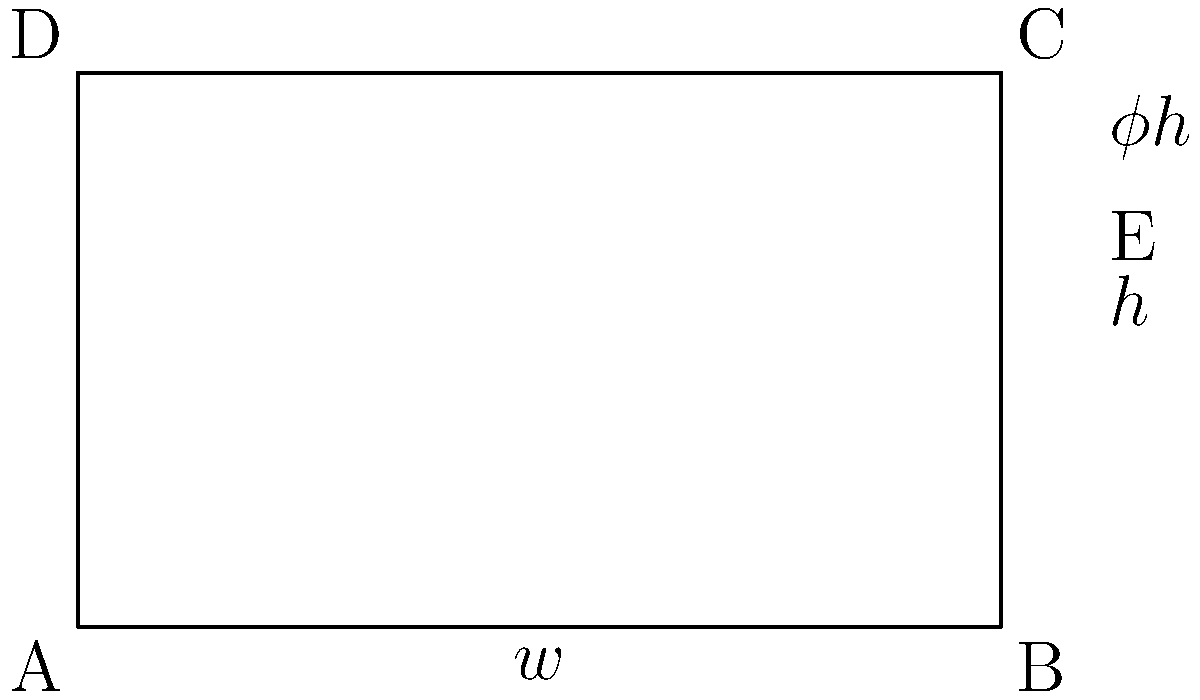As an e-book startup owner, you're designing an e-reader screen using the golden ratio for optimal readability. If the screen's width is $w$ and its height is $h$, and point E divides the height according to the golden ratio $\phi = \frac{1+\sqrt{5}}{2}$, what is the ratio of $w$ to $h$ that satisfies the golden ratio property? To solve this problem, we'll follow these steps:

1) The golden ratio $\phi$ is defined as $\phi = \frac{1+\sqrt{5}}{2} \approx 1.618$.

2) In the rectangle ABCD, BE represents the division of the height according to the golden ratio. This means:

   $\frac{BC}{BE} = \phi$

3) We can express this as:
   
   $\frac{h}{\phi h - h} = \phi$

4) Simplify:
   
   $\frac{h}{(\phi-1)h} = \phi$

5) Cancel out $h$:
   
   $\frac{1}{\phi-1} = \phi$

6) Cross multiply:
   
   $1 = \phi(\phi-1) = \phi^2 - \phi$

7) Rearrange:
   
   $\phi^2 - \phi - 1 = 0$

8) This is the defining equation for $\phi$. For the rectangle to have the golden ratio property, its width-to-height ratio should be $\phi$.

Therefore, $\frac{w}{h} = \phi = \frac{1+\sqrt{5}}{2}$.
Answer: $\frac{w}{h} = \frac{1+\sqrt{5}}{2}$ 